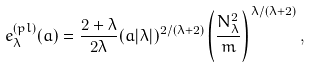<formula> <loc_0><loc_0><loc_500><loc_500>e _ { \lambda } ^ { ( p l ) } ( a ) = \frac { 2 + \lambda } { 2 \lambda } ( a | \lambda | ) ^ { 2 / ( \lambda + 2 ) } \left ( \frac { N _ { \lambda } ^ { 2 } } { m } \right ) ^ { \lambda / ( \lambda + 2 ) } ,</formula> 